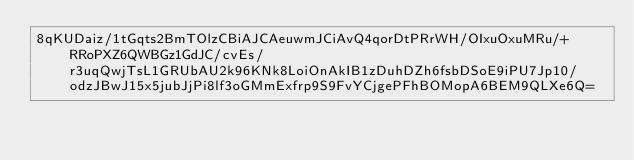<code> <loc_0><loc_0><loc_500><loc_500><_SML_>8qKUDaiz/1tGqts2BmTOlzCBiAJCAeuwmJCiAvQ4qorDtPRrWH/OIxuOxuMRu/+RRoPXZ6QWBGz1GdJC/cvEs/r3uqQwjTsL1GRUbAU2k96KNk8LoiOnAkIB1zDuhDZh6fsbDSoE9iPU7Jp10/odzJBwJ15x5jubJjPi8lf3oGMmExfrp9S9FvYCjgePFhBOMopA6BEM9QLXe6Q=</code> 